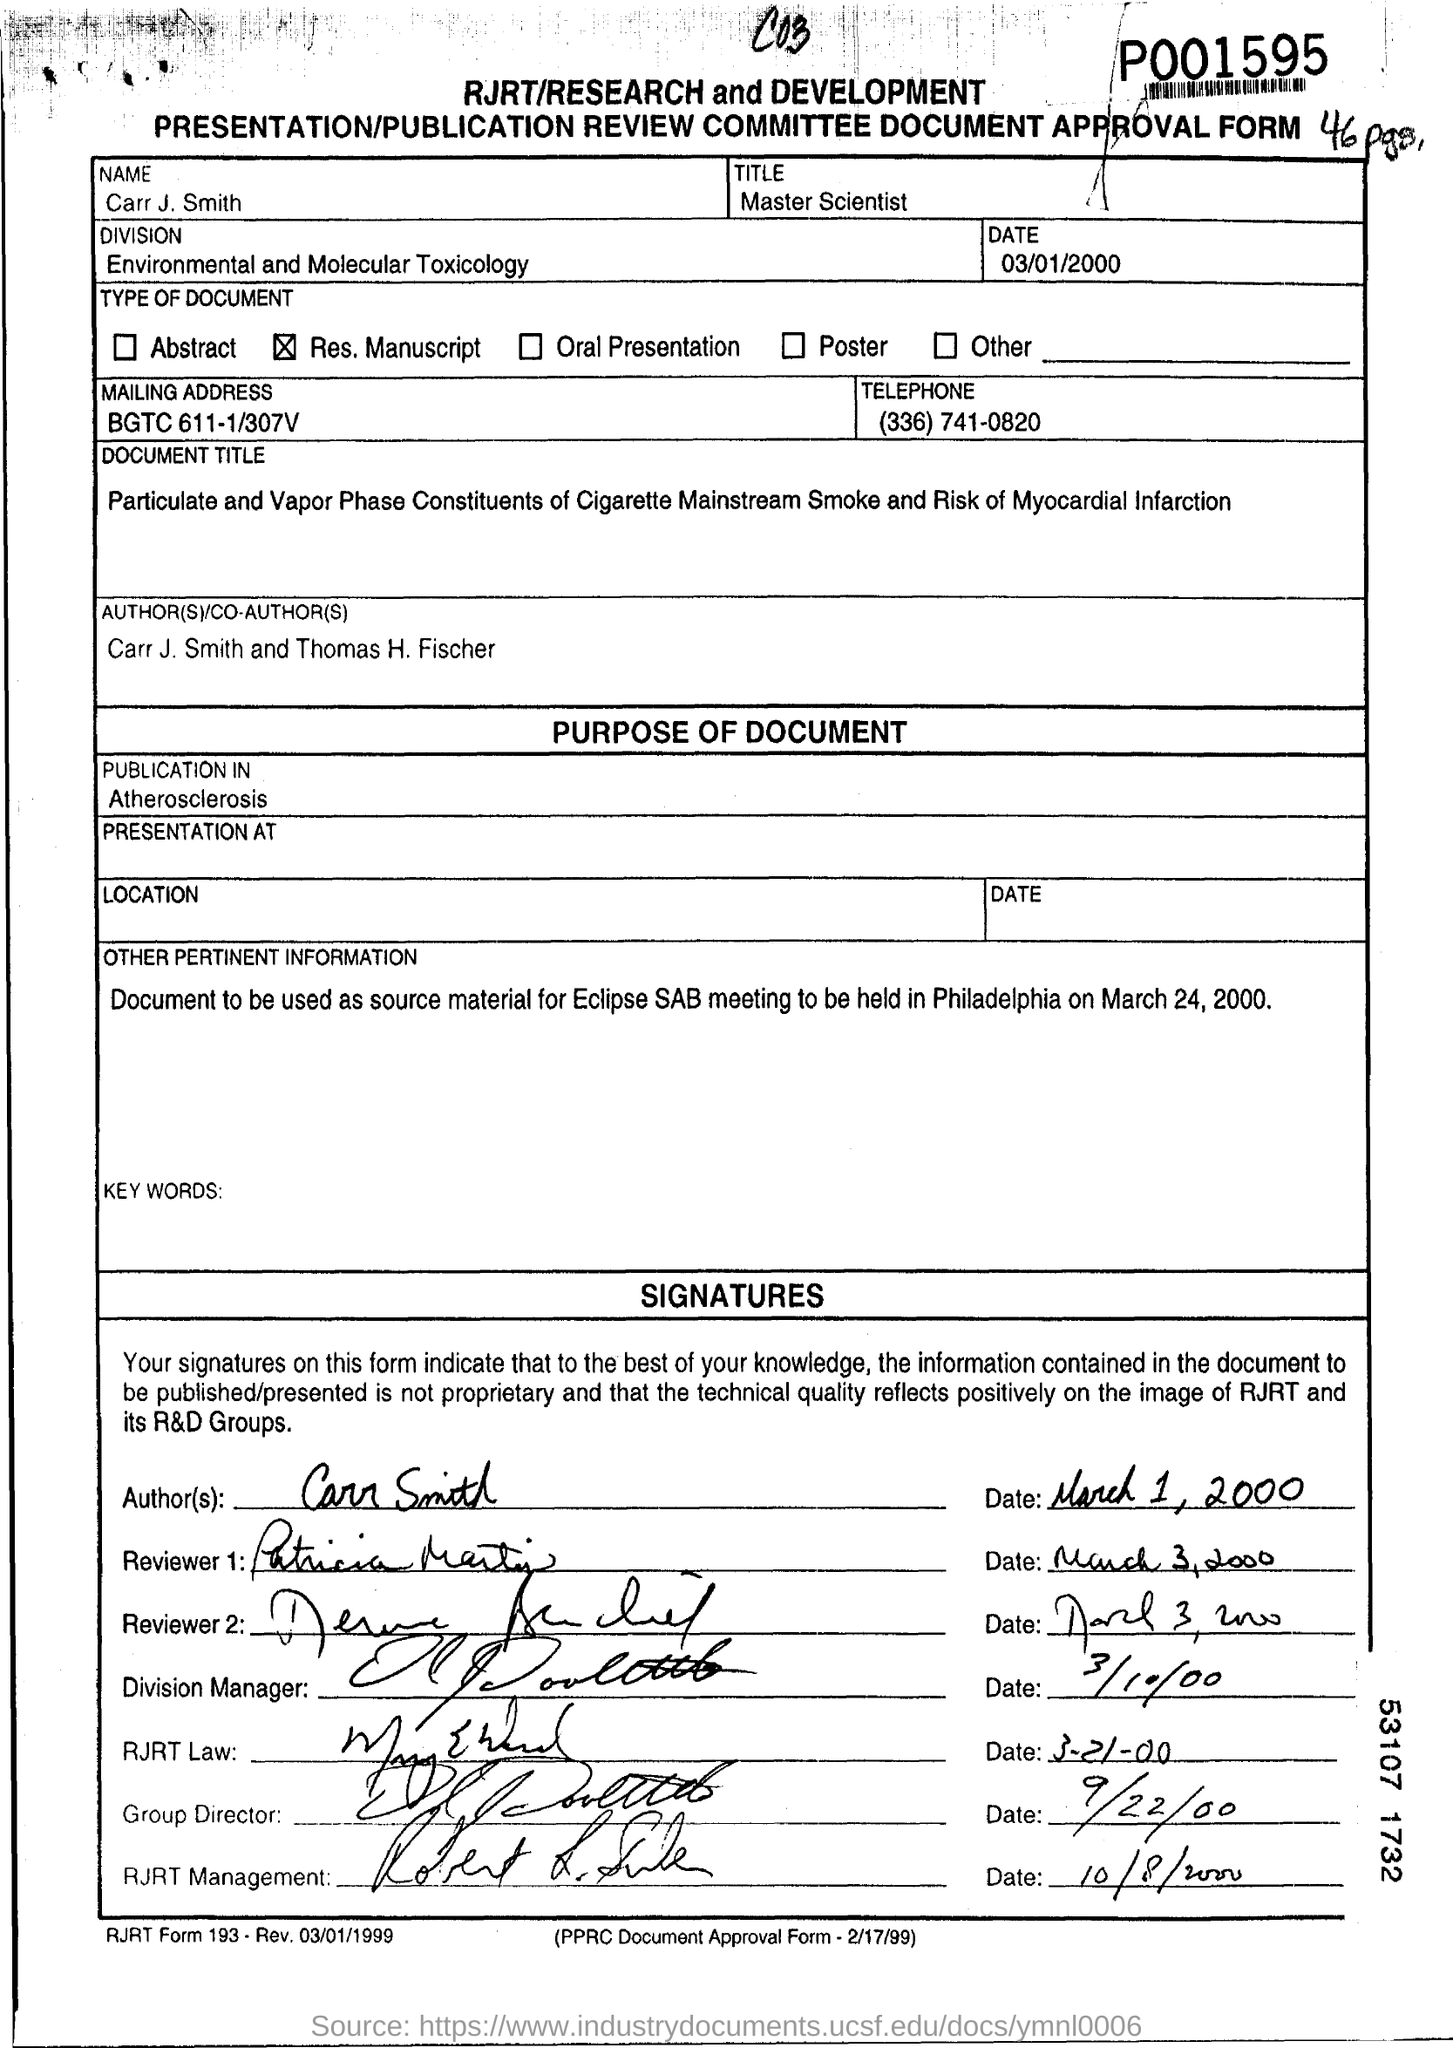What name is mentioned on the publication review committee document approval from number 46 ?
Provide a short and direct response. Carr . j .smith. What is the title of Carr J. Smith mentioned in the form?
Make the answer very short. Master Scientist. What division is mentioned on the publication review committee document approval from number 46 ?
Provide a short and direct response. Environmental and molecular toxicology. What is the telephone number mentioned in the form?
Provide a short and direct response. (336) 741-0820. 